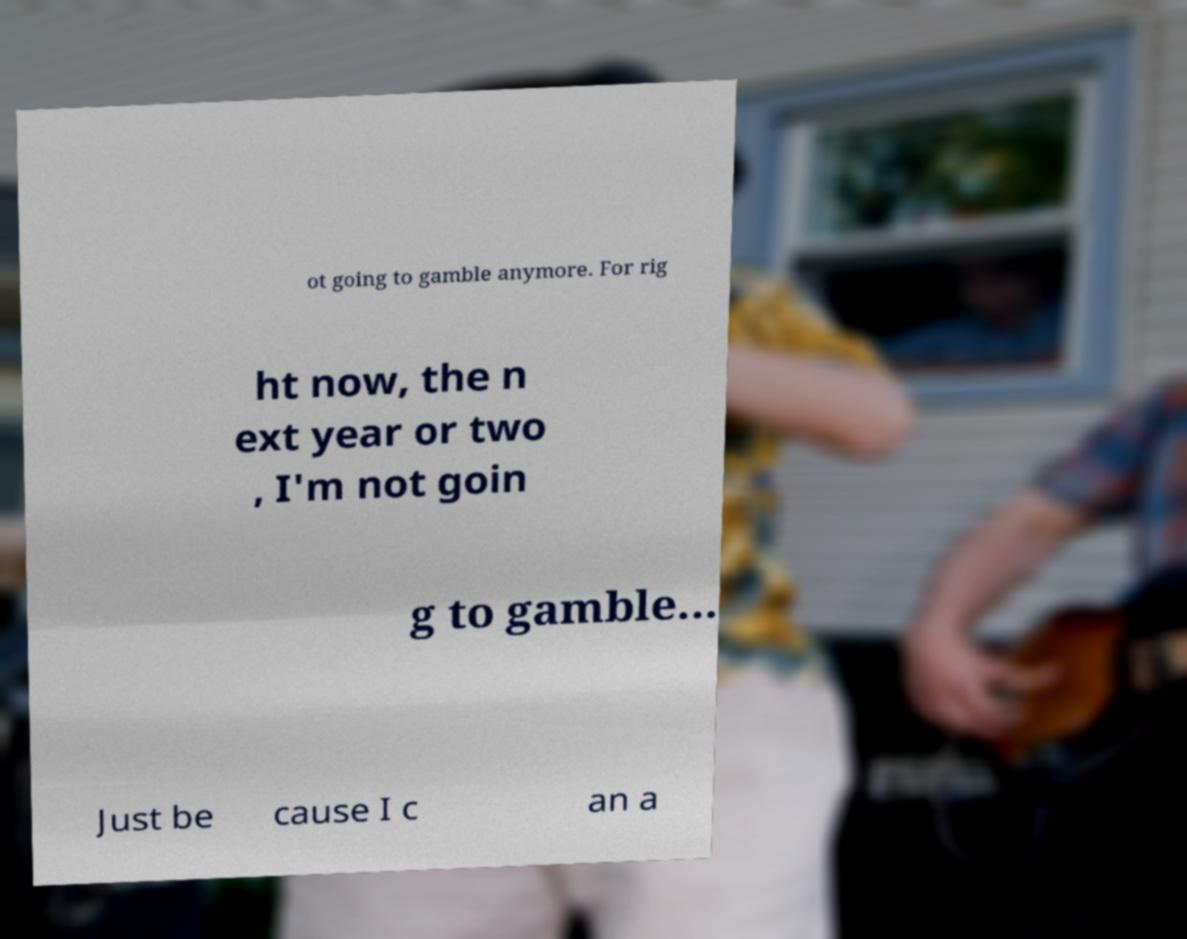I need the written content from this picture converted into text. Can you do that? ot going to gamble anymore. For rig ht now, the n ext year or two , I'm not goin g to gamble... Just be cause I c an a 